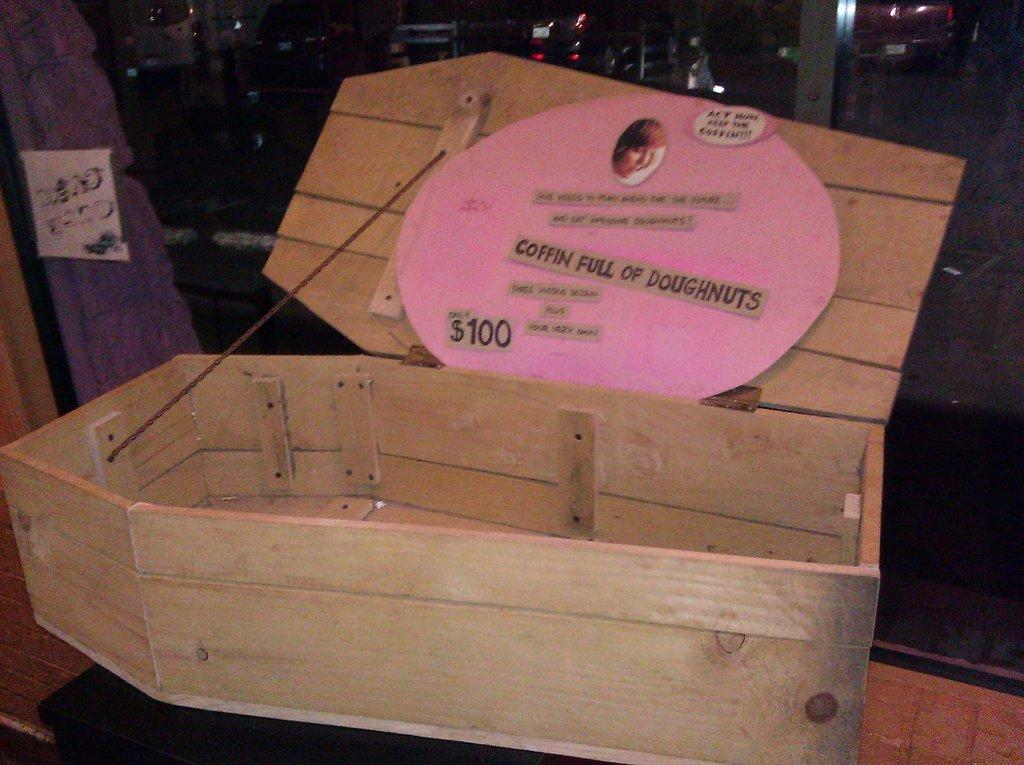<image>
Render a clear and concise summary of the photo. A wooden coffin is being used to sell doughnuts for $100. 